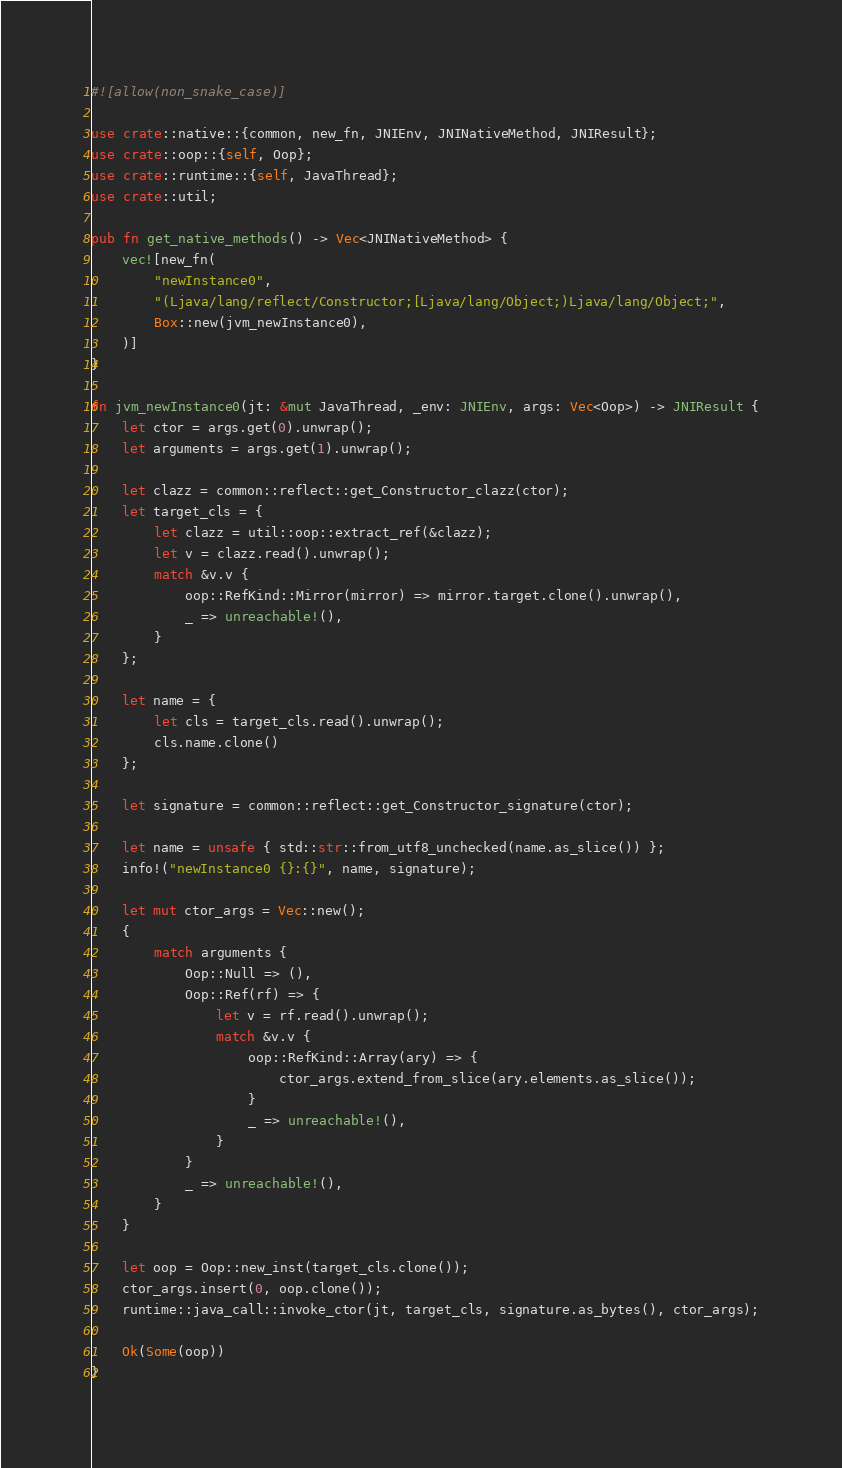<code> <loc_0><loc_0><loc_500><loc_500><_Rust_>#![allow(non_snake_case)]

use crate::native::{common, new_fn, JNIEnv, JNINativeMethod, JNIResult};
use crate::oop::{self, Oop};
use crate::runtime::{self, JavaThread};
use crate::util;

pub fn get_native_methods() -> Vec<JNINativeMethod> {
    vec![new_fn(
        "newInstance0",
        "(Ljava/lang/reflect/Constructor;[Ljava/lang/Object;)Ljava/lang/Object;",
        Box::new(jvm_newInstance0),
    )]
}

fn jvm_newInstance0(jt: &mut JavaThread, _env: JNIEnv, args: Vec<Oop>) -> JNIResult {
    let ctor = args.get(0).unwrap();
    let arguments = args.get(1).unwrap();

    let clazz = common::reflect::get_Constructor_clazz(ctor);
    let target_cls = {
        let clazz = util::oop::extract_ref(&clazz);
        let v = clazz.read().unwrap();
        match &v.v {
            oop::RefKind::Mirror(mirror) => mirror.target.clone().unwrap(),
            _ => unreachable!(),
        }
    };

    let name = {
        let cls = target_cls.read().unwrap();
        cls.name.clone()
    };

    let signature = common::reflect::get_Constructor_signature(ctor);

    let name = unsafe { std::str::from_utf8_unchecked(name.as_slice()) };
    info!("newInstance0 {}:{}", name, signature);

    let mut ctor_args = Vec::new();
    {
        match arguments {
            Oop::Null => (),
            Oop::Ref(rf) => {
                let v = rf.read().unwrap();
                match &v.v {
                    oop::RefKind::Array(ary) => {
                        ctor_args.extend_from_slice(ary.elements.as_slice());
                    }
                    _ => unreachable!(),
                }
            }
            _ => unreachable!(),
        }
    }

    let oop = Oop::new_inst(target_cls.clone());
    ctor_args.insert(0, oop.clone());
    runtime::java_call::invoke_ctor(jt, target_cls, signature.as_bytes(), ctor_args);

    Ok(Some(oop))
}
</code> 